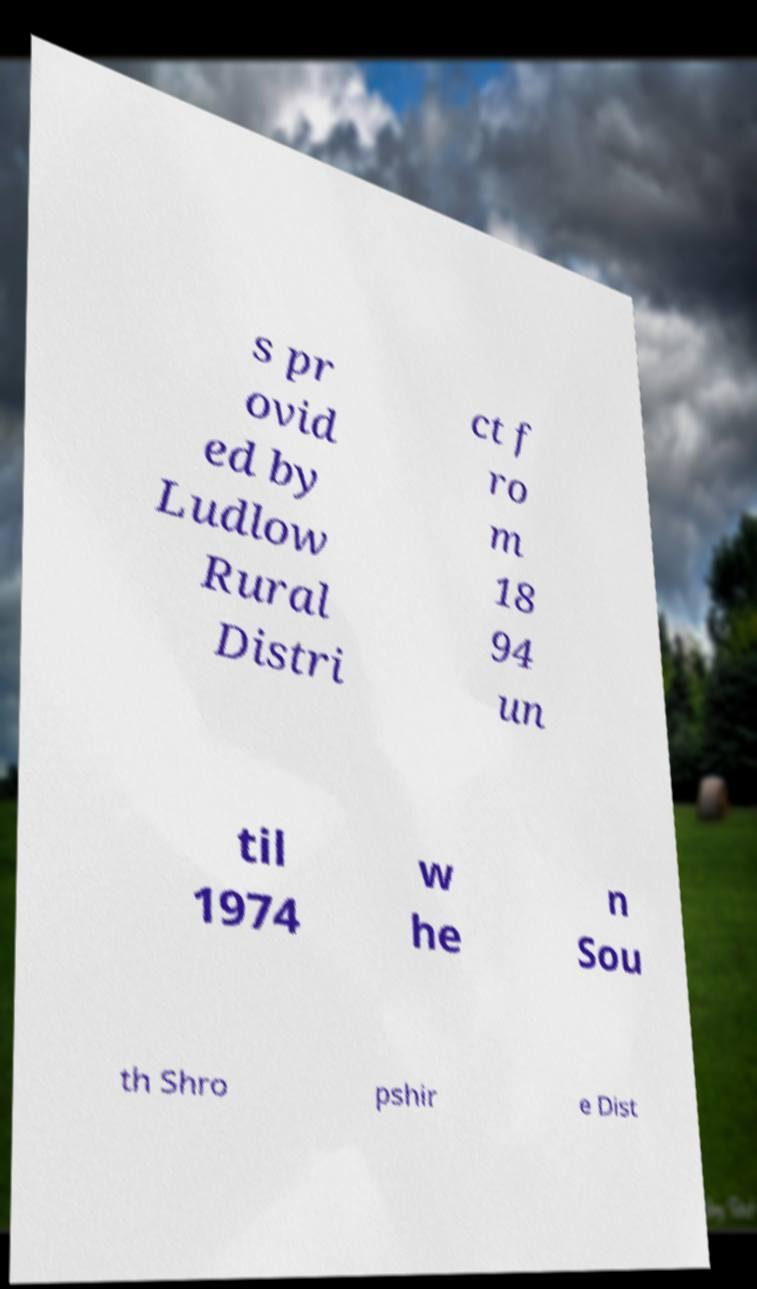Can you read and provide the text displayed in the image?This photo seems to have some interesting text. Can you extract and type it out for me? s pr ovid ed by Ludlow Rural Distri ct f ro m 18 94 un til 1974 w he n Sou th Shro pshir e Dist 